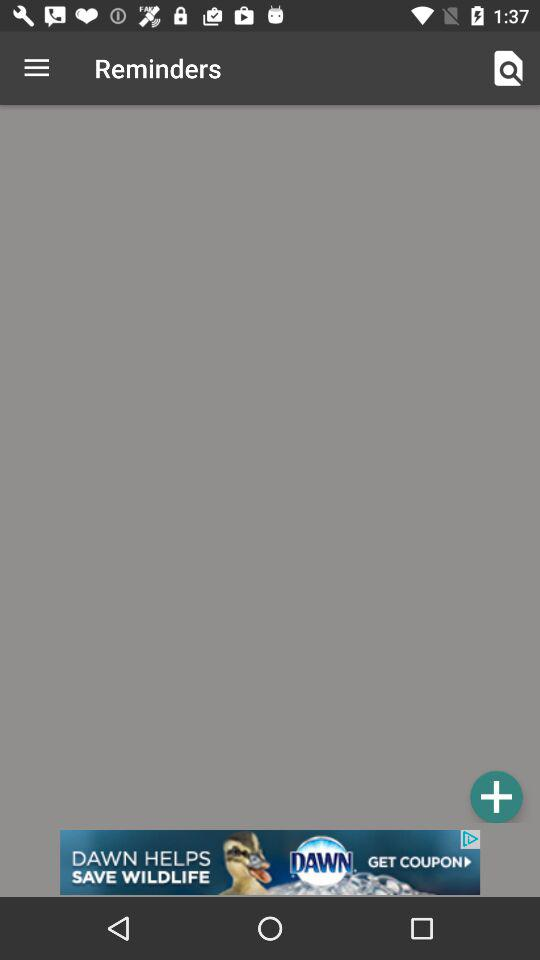What is the application name? The application name is "Reminders". 